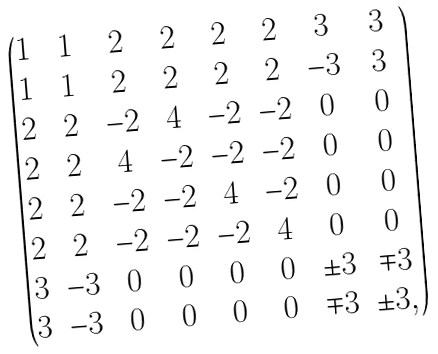<formula> <loc_0><loc_0><loc_500><loc_500>\begin{pmatrix} 1 & 1 & 2 & 2 & 2 & 2 & 3 & 3 \\ 1 & 1 & 2 & 2 & 2 & 2 & - 3 & 3 \\ 2 & 2 & - 2 & 4 & - 2 & - 2 & 0 & 0 \\ 2 & 2 & 4 & - 2 & - 2 & - 2 & 0 & 0 \\ 2 & 2 & - 2 & - 2 & 4 & - 2 & 0 & 0 \\ 2 & 2 & - 2 & - 2 & - 2 & 4 & 0 & 0 \\ 3 & - 3 & 0 & 0 & 0 & 0 & \pm 3 & \mp 3 \\ 3 & - 3 & 0 & 0 & 0 & 0 & \mp 3 & \pm 3 , \end{pmatrix}</formula> 